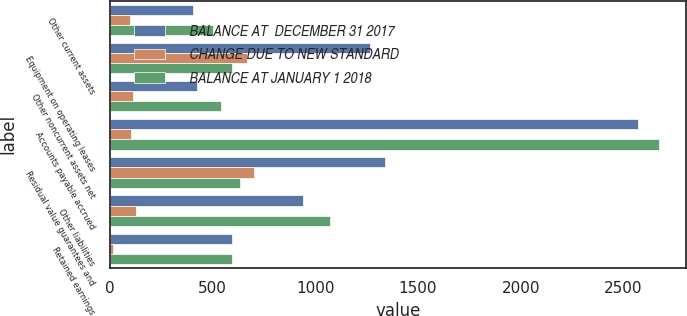<chart> <loc_0><loc_0><loc_500><loc_500><stacked_bar_chart><ecel><fcel>Other current assets<fcel>Equipment on operating leases<fcel>Other noncurrent assets net<fcel>Accounts payable accrued<fcel>Residual value guarantees and<fcel>Other liabilities<fcel>Retained earnings<nl><fcel>BALANCE AT  DECEMBER 31 2017<fcel>404.4<fcel>1265.7<fcel>425.2<fcel>2569.5<fcel>1339<fcel>939.8<fcel>596.9<nl><fcel>CHANGE DUE TO NEW STANDARD<fcel>100<fcel>668.8<fcel>115<fcel>103.1<fcel>703.8<fcel>129.8<fcel>17.1<nl><fcel>BALANCE AT JANUARY 1 2018<fcel>504.4<fcel>596.9<fcel>540.2<fcel>2672.6<fcel>635.2<fcel>1069.6<fcel>596.9<nl></chart> 